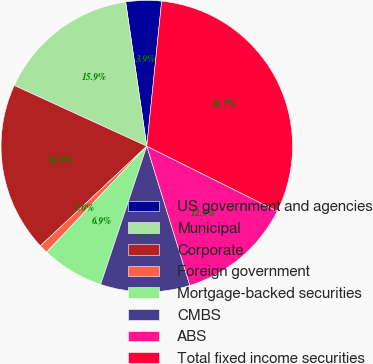Convert chart to OTSL. <chart><loc_0><loc_0><loc_500><loc_500><pie_chart><fcel>US government and agencies<fcel>Municipal<fcel>Corporate<fcel>Foreign government<fcel>Mortgage-backed securities<fcel>CMBS<fcel>ABS<fcel>Total fixed income securities<nl><fcel>3.94%<fcel>15.85%<fcel>18.82%<fcel>0.97%<fcel>6.92%<fcel>9.9%<fcel>12.87%<fcel>30.73%<nl></chart> 